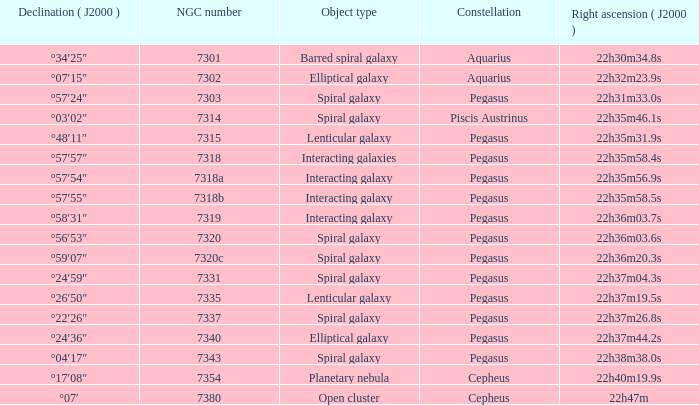What is Pegasus' right ascension with a 7318a NGC? 22h35m56.9s. 